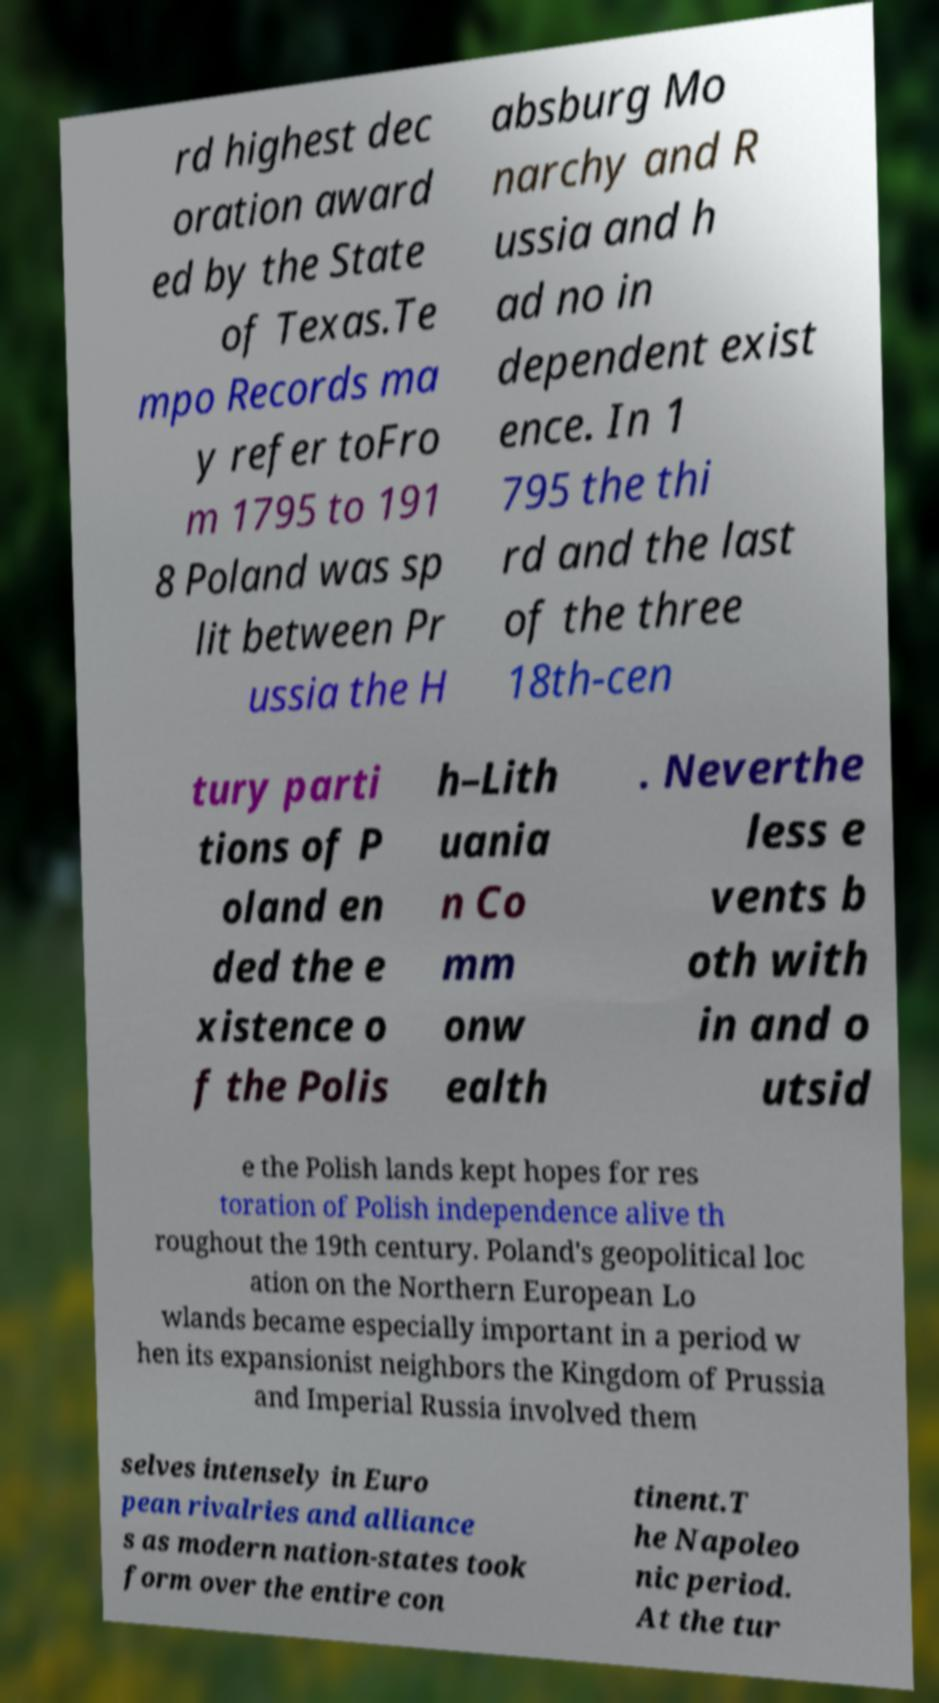Please identify and transcribe the text found in this image. rd highest dec oration award ed by the State of Texas.Te mpo Records ma y refer toFro m 1795 to 191 8 Poland was sp lit between Pr ussia the H absburg Mo narchy and R ussia and h ad no in dependent exist ence. In 1 795 the thi rd and the last of the three 18th-cen tury parti tions of P oland en ded the e xistence o f the Polis h–Lith uania n Co mm onw ealth . Neverthe less e vents b oth with in and o utsid e the Polish lands kept hopes for res toration of Polish independence alive th roughout the 19th century. Poland's geopolitical loc ation on the Northern European Lo wlands became especially important in a period w hen its expansionist neighbors the Kingdom of Prussia and Imperial Russia involved them selves intensely in Euro pean rivalries and alliance s as modern nation-states took form over the entire con tinent.T he Napoleo nic period. At the tur 